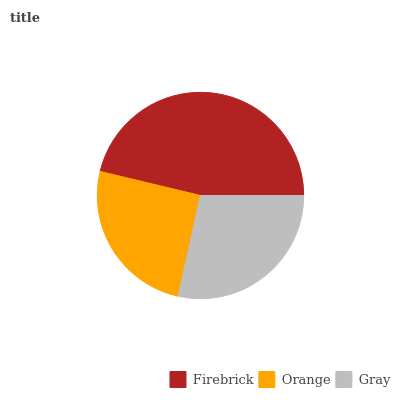Is Orange the minimum?
Answer yes or no. Yes. Is Firebrick the maximum?
Answer yes or no. Yes. Is Gray the minimum?
Answer yes or no. No. Is Gray the maximum?
Answer yes or no. No. Is Gray greater than Orange?
Answer yes or no. Yes. Is Orange less than Gray?
Answer yes or no. Yes. Is Orange greater than Gray?
Answer yes or no. No. Is Gray less than Orange?
Answer yes or no. No. Is Gray the high median?
Answer yes or no. Yes. Is Gray the low median?
Answer yes or no. Yes. Is Orange the high median?
Answer yes or no. No. Is Firebrick the low median?
Answer yes or no. No. 